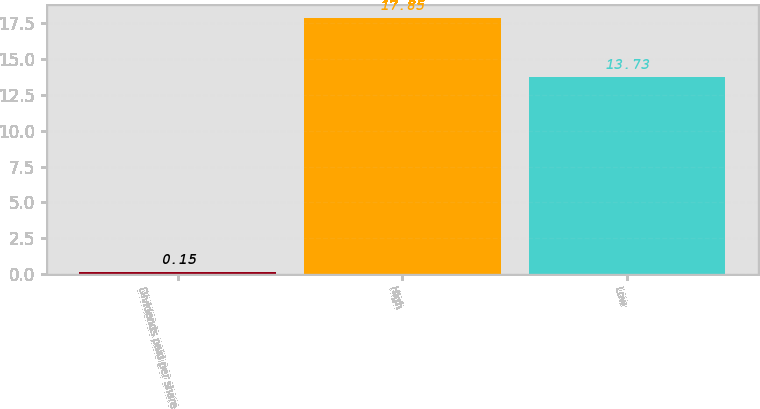Convert chart to OTSL. <chart><loc_0><loc_0><loc_500><loc_500><bar_chart><fcel>Dividends paid per share<fcel>High<fcel>Low<nl><fcel>0.15<fcel>17.85<fcel>13.73<nl></chart> 